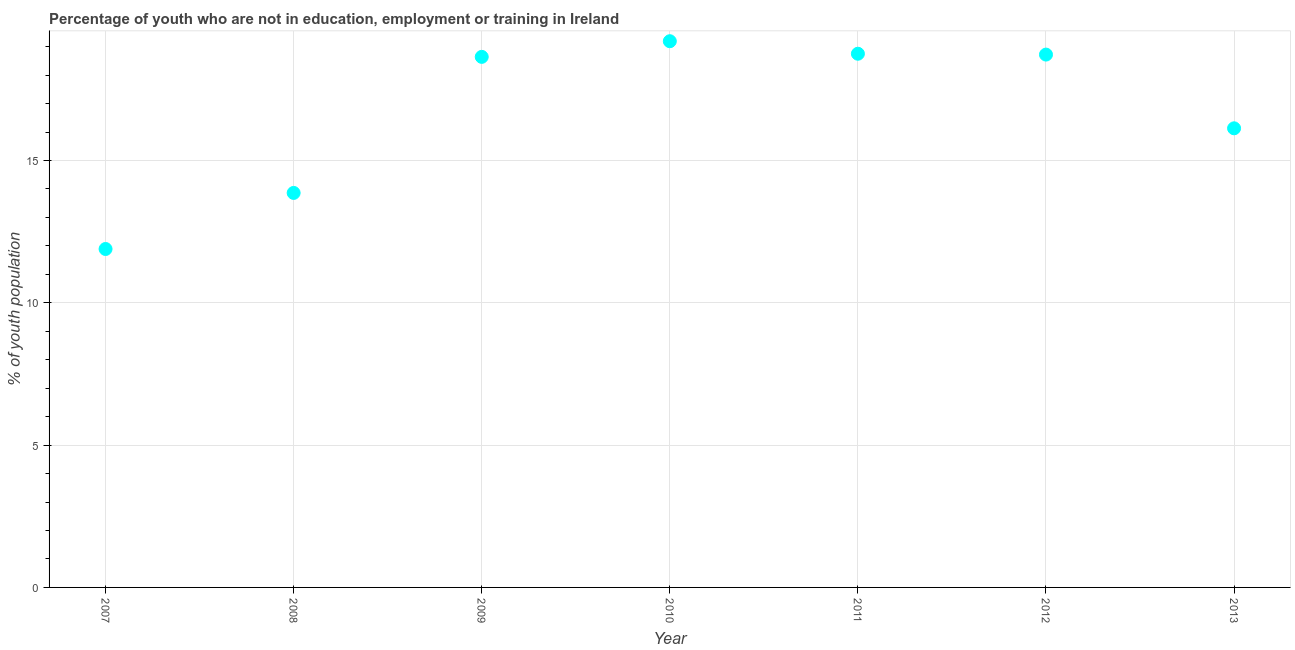What is the unemployed youth population in 2011?
Your answer should be compact. 18.75. Across all years, what is the maximum unemployed youth population?
Your answer should be compact. 19.19. Across all years, what is the minimum unemployed youth population?
Make the answer very short. 11.89. What is the sum of the unemployed youth population?
Provide a short and direct response. 117.18. What is the difference between the unemployed youth population in 2007 and 2012?
Your answer should be very brief. -6.83. What is the average unemployed youth population per year?
Keep it short and to the point. 16.74. What is the median unemployed youth population?
Offer a terse response. 18.64. Do a majority of the years between 2012 and 2013 (inclusive) have unemployed youth population greater than 16 %?
Keep it short and to the point. Yes. What is the ratio of the unemployed youth population in 2008 to that in 2013?
Make the answer very short. 0.86. What is the difference between the highest and the second highest unemployed youth population?
Make the answer very short. 0.44. What is the difference between the highest and the lowest unemployed youth population?
Offer a terse response. 7.3. Does the unemployed youth population monotonically increase over the years?
Your response must be concise. No. How many dotlines are there?
Provide a succinct answer. 1. What is the title of the graph?
Provide a short and direct response. Percentage of youth who are not in education, employment or training in Ireland. What is the label or title of the Y-axis?
Provide a short and direct response. % of youth population. What is the % of youth population in 2007?
Your response must be concise. 11.89. What is the % of youth population in 2008?
Your answer should be very brief. 13.86. What is the % of youth population in 2009?
Offer a very short reply. 18.64. What is the % of youth population in 2010?
Offer a terse response. 19.19. What is the % of youth population in 2011?
Your answer should be very brief. 18.75. What is the % of youth population in 2012?
Your answer should be compact. 18.72. What is the % of youth population in 2013?
Make the answer very short. 16.13. What is the difference between the % of youth population in 2007 and 2008?
Ensure brevity in your answer.  -1.97. What is the difference between the % of youth population in 2007 and 2009?
Provide a succinct answer. -6.75. What is the difference between the % of youth population in 2007 and 2010?
Provide a succinct answer. -7.3. What is the difference between the % of youth population in 2007 and 2011?
Offer a very short reply. -6.86. What is the difference between the % of youth population in 2007 and 2012?
Offer a very short reply. -6.83. What is the difference between the % of youth population in 2007 and 2013?
Provide a short and direct response. -4.24. What is the difference between the % of youth population in 2008 and 2009?
Give a very brief answer. -4.78. What is the difference between the % of youth population in 2008 and 2010?
Your response must be concise. -5.33. What is the difference between the % of youth population in 2008 and 2011?
Offer a terse response. -4.89. What is the difference between the % of youth population in 2008 and 2012?
Provide a short and direct response. -4.86. What is the difference between the % of youth population in 2008 and 2013?
Your answer should be very brief. -2.27. What is the difference between the % of youth population in 2009 and 2010?
Make the answer very short. -0.55. What is the difference between the % of youth population in 2009 and 2011?
Provide a short and direct response. -0.11. What is the difference between the % of youth population in 2009 and 2012?
Provide a succinct answer. -0.08. What is the difference between the % of youth population in 2009 and 2013?
Your answer should be compact. 2.51. What is the difference between the % of youth population in 2010 and 2011?
Give a very brief answer. 0.44. What is the difference between the % of youth population in 2010 and 2012?
Offer a very short reply. 0.47. What is the difference between the % of youth population in 2010 and 2013?
Your answer should be compact. 3.06. What is the difference between the % of youth population in 2011 and 2013?
Ensure brevity in your answer.  2.62. What is the difference between the % of youth population in 2012 and 2013?
Make the answer very short. 2.59. What is the ratio of the % of youth population in 2007 to that in 2008?
Provide a succinct answer. 0.86. What is the ratio of the % of youth population in 2007 to that in 2009?
Keep it short and to the point. 0.64. What is the ratio of the % of youth population in 2007 to that in 2010?
Your response must be concise. 0.62. What is the ratio of the % of youth population in 2007 to that in 2011?
Offer a very short reply. 0.63. What is the ratio of the % of youth population in 2007 to that in 2012?
Ensure brevity in your answer.  0.64. What is the ratio of the % of youth population in 2007 to that in 2013?
Offer a terse response. 0.74. What is the ratio of the % of youth population in 2008 to that in 2009?
Your answer should be compact. 0.74. What is the ratio of the % of youth population in 2008 to that in 2010?
Give a very brief answer. 0.72. What is the ratio of the % of youth population in 2008 to that in 2011?
Provide a succinct answer. 0.74. What is the ratio of the % of youth population in 2008 to that in 2012?
Provide a short and direct response. 0.74. What is the ratio of the % of youth population in 2008 to that in 2013?
Your response must be concise. 0.86. What is the ratio of the % of youth population in 2009 to that in 2011?
Your answer should be very brief. 0.99. What is the ratio of the % of youth population in 2009 to that in 2012?
Keep it short and to the point. 1. What is the ratio of the % of youth population in 2009 to that in 2013?
Keep it short and to the point. 1.16. What is the ratio of the % of youth population in 2010 to that in 2011?
Your answer should be very brief. 1.02. What is the ratio of the % of youth population in 2010 to that in 2012?
Provide a short and direct response. 1.02. What is the ratio of the % of youth population in 2010 to that in 2013?
Offer a very short reply. 1.19. What is the ratio of the % of youth population in 2011 to that in 2012?
Offer a terse response. 1. What is the ratio of the % of youth population in 2011 to that in 2013?
Keep it short and to the point. 1.16. What is the ratio of the % of youth population in 2012 to that in 2013?
Provide a succinct answer. 1.16. 